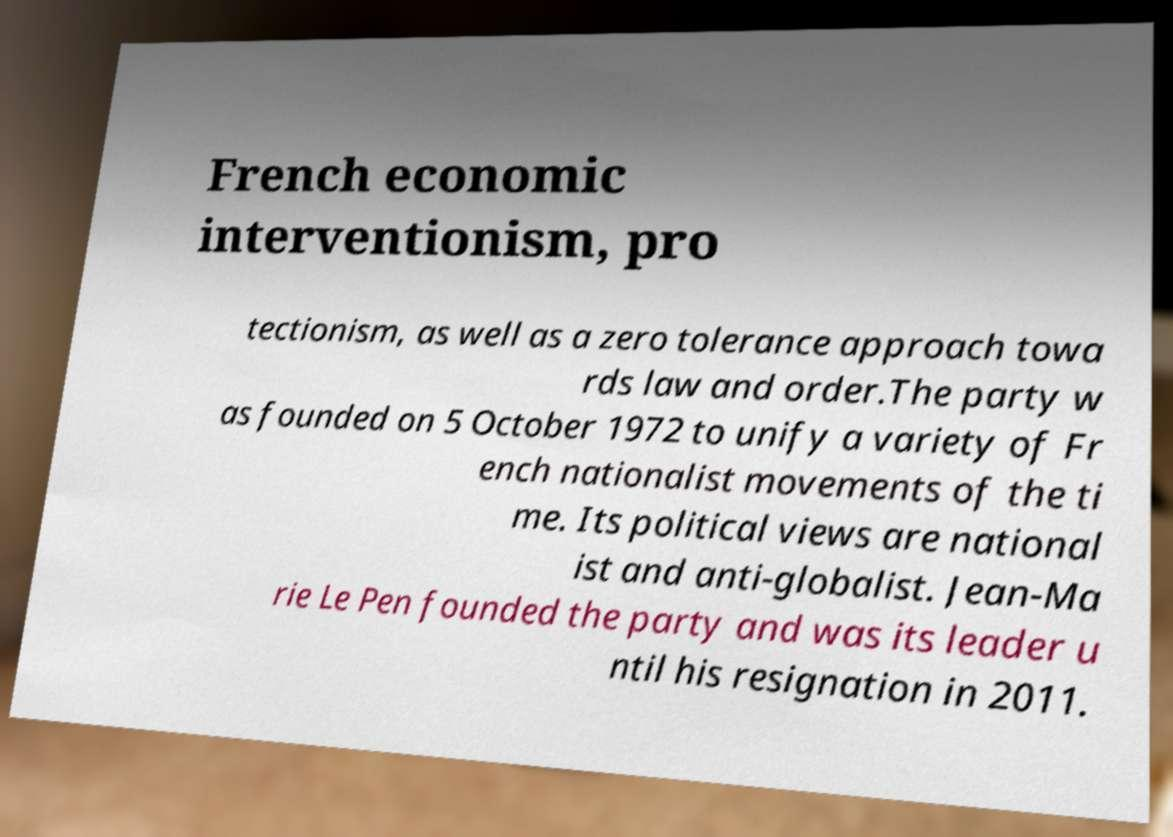I need the written content from this picture converted into text. Can you do that? French economic interventionism, pro tectionism, as well as a zero tolerance approach towa rds law and order.The party w as founded on 5 October 1972 to unify a variety of Fr ench nationalist movements of the ti me. Its political views are national ist and anti-globalist. Jean-Ma rie Le Pen founded the party and was its leader u ntil his resignation in 2011. 